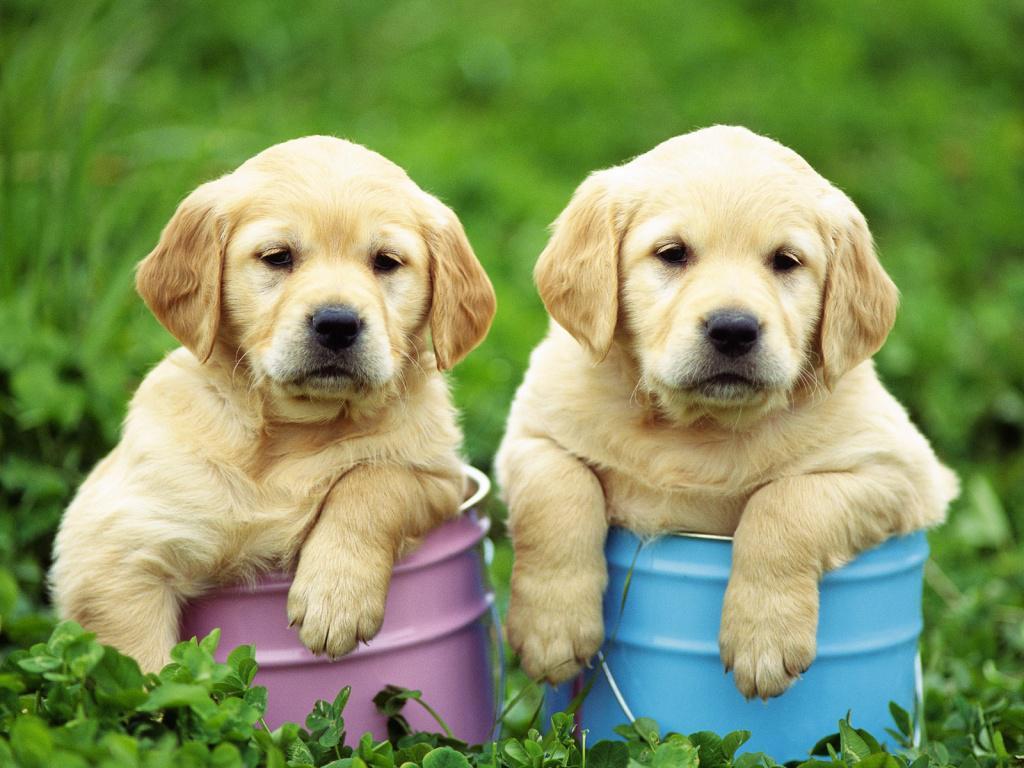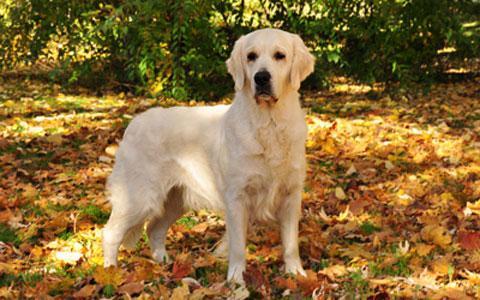The first image is the image on the left, the second image is the image on the right. Analyze the images presented: Is the assertion "One image shows exactly two retrievers, which are side-by-side." valid? Answer yes or no. Yes. 